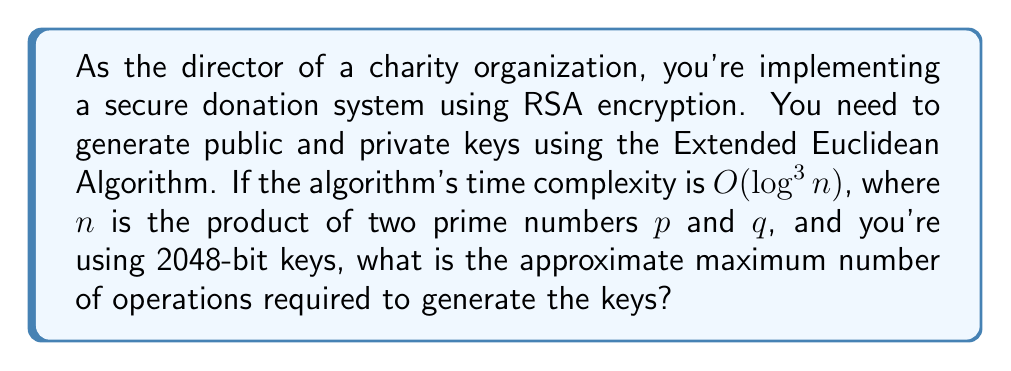Solve this math problem. Let's approach this step-by-step:

1) In RSA, $n = p \times q$, where $p$ and $q$ are prime numbers.

2) For 2048-bit keys, $n$ is a 2048-bit number.

3) The time complexity of the Extended Euclidean Algorithm is $O(\log^3 n)$.

4) We need to find $\log^3 n$:
   
   $n$ is a 2048-bit number, so $\log_2 n = 2048$

5) Converting to base 10:
   
   $\log n = 2048 \times \log 2 \approx 2048 \times 0.301 \approx 616.5$

6) Now we cube this value:

   $(\log n)^3 \approx 616.5^3 \approx 234,387,440$

7) The $O$ notation represents the upper bound, so this is the approximate maximum number of operations.
Answer: $234,387,440$ operations 